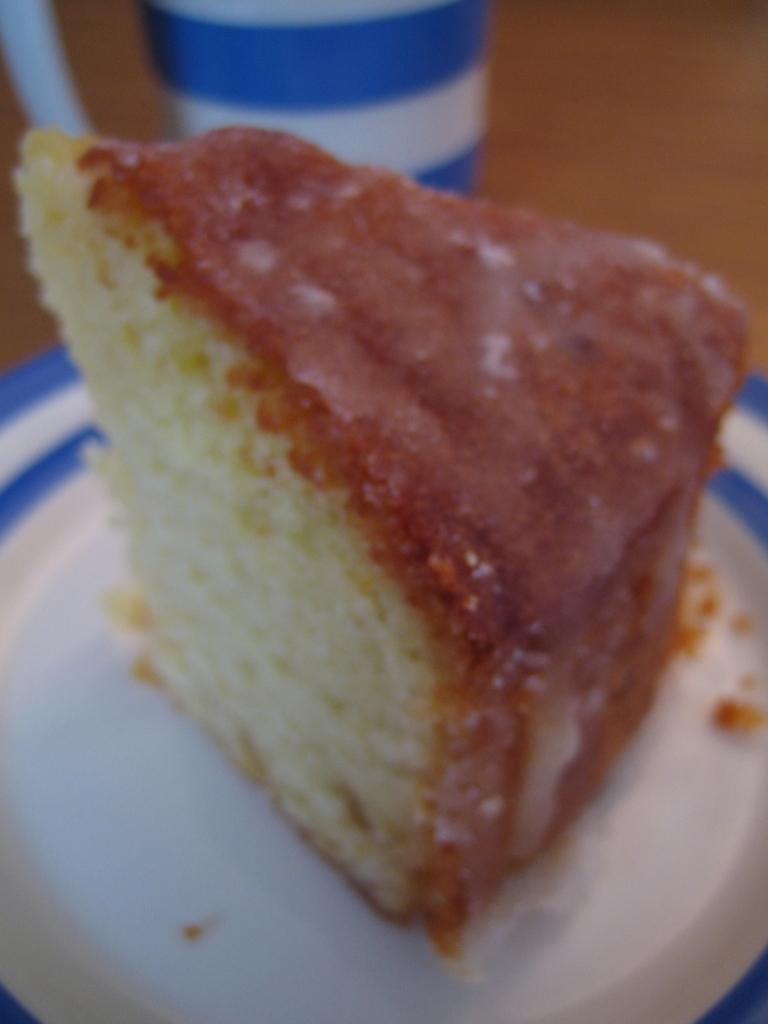What is the main subject of the image? There is a piece of cake in the image. How is the cake presented? The piece of cake is cut. What is the color of the plate on which the cake is placed? The cake is placed on a white color plate. Can you describe the object in the background of the image? The object has blue and white colors. What type of seed can be seen growing in the image? There is no seed or plant visible in the image; it features a piece of cake on a plate with an object in the background. 